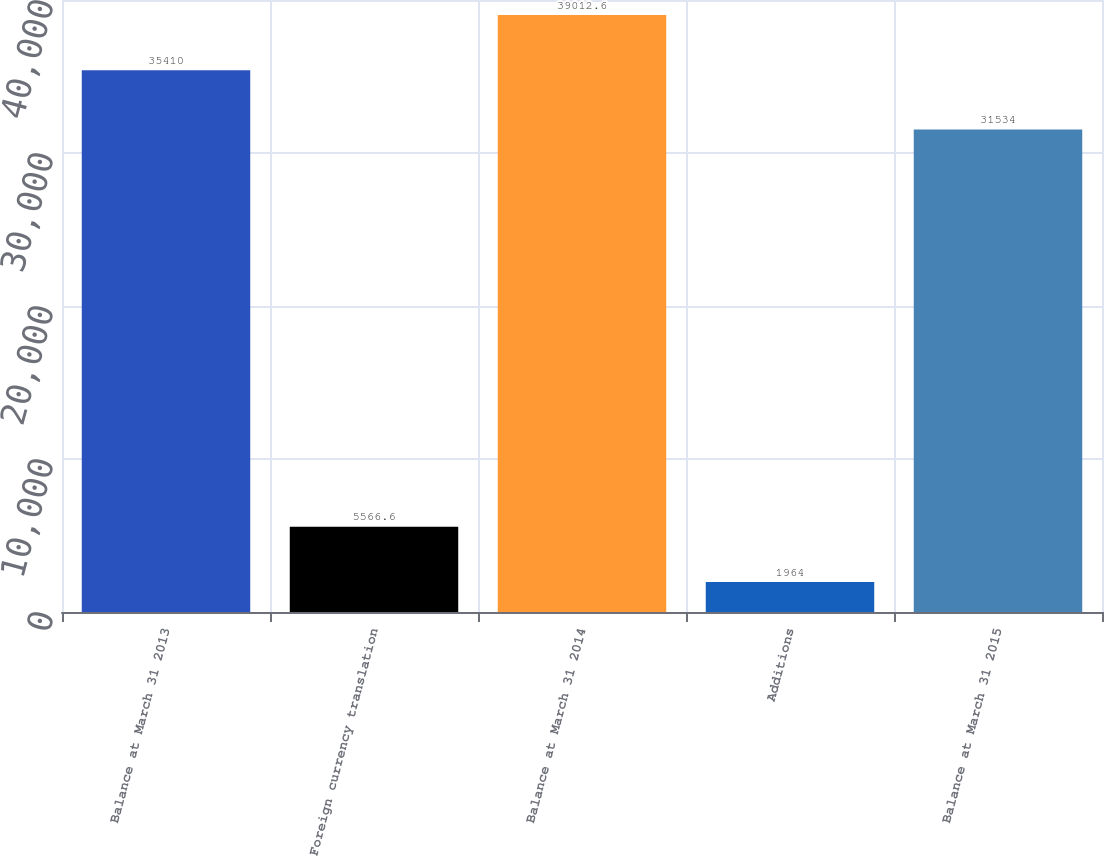<chart> <loc_0><loc_0><loc_500><loc_500><bar_chart><fcel>Balance at March 31 2013<fcel>Foreign currency translation<fcel>Balance at March 31 2014<fcel>Additions<fcel>Balance at March 31 2015<nl><fcel>35410<fcel>5566.6<fcel>39012.6<fcel>1964<fcel>31534<nl></chart> 